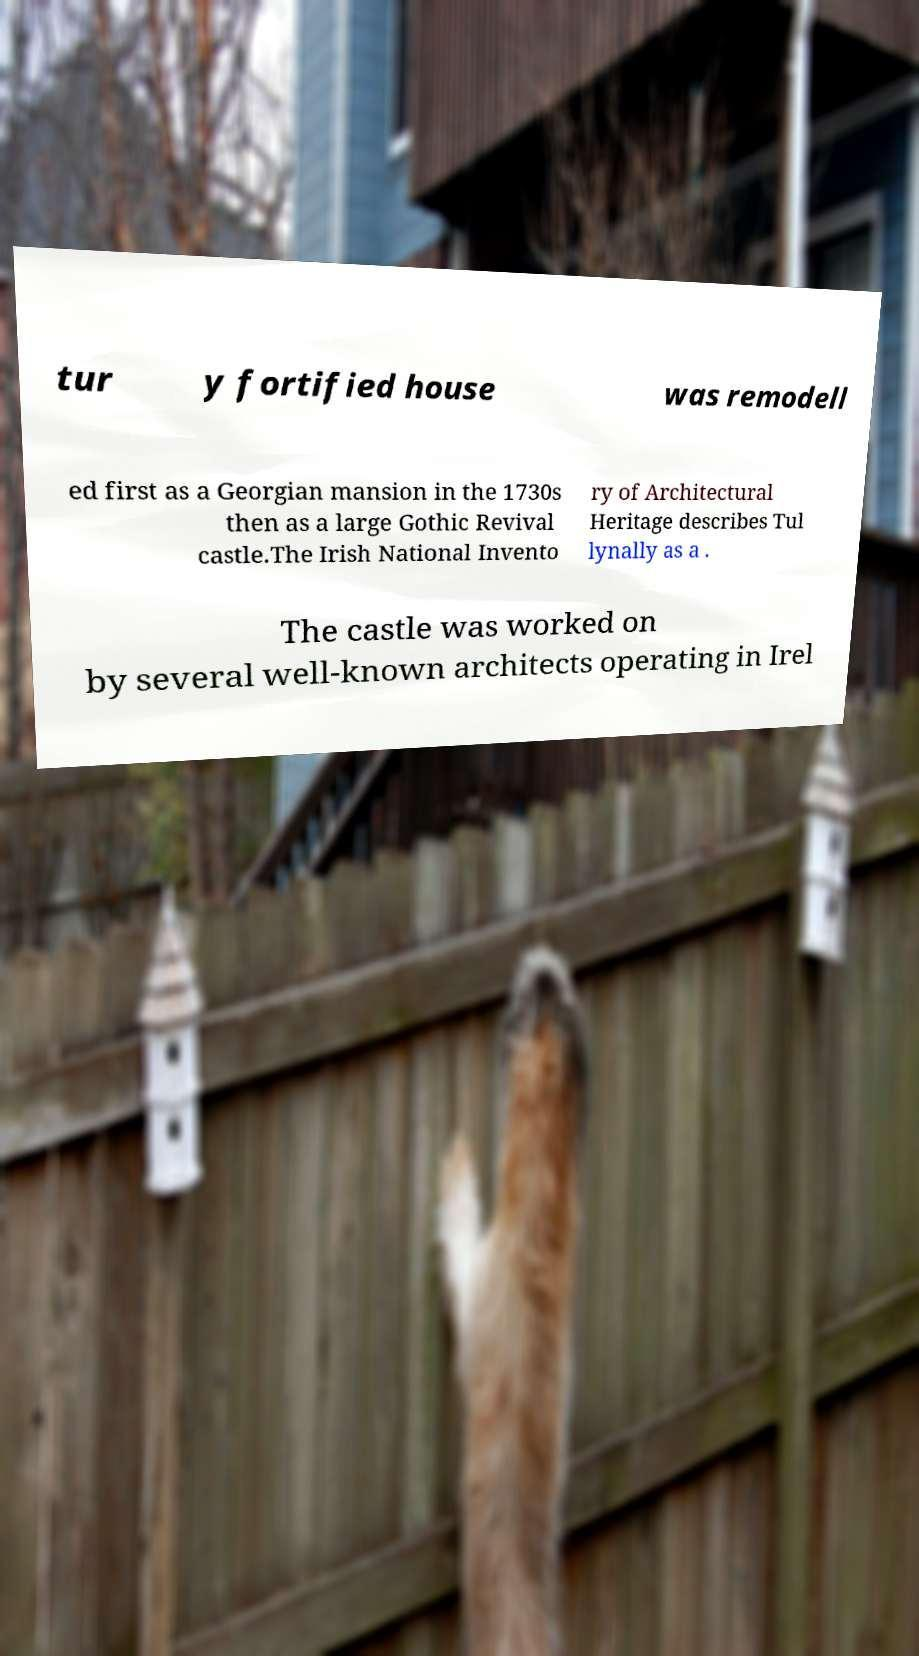Can you accurately transcribe the text from the provided image for me? tur y fortified house was remodell ed first as a Georgian mansion in the 1730s then as a large Gothic Revival castle.The Irish National Invento ry of Architectural Heritage describes Tul lynally as a . The castle was worked on by several well-known architects operating in Irel 